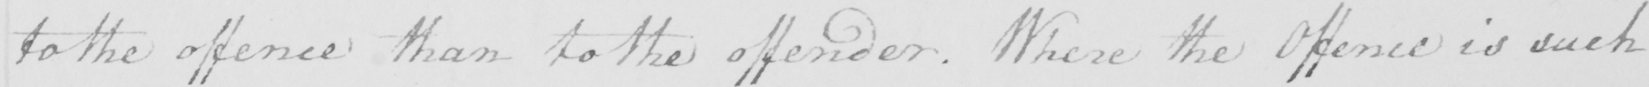Can you read and transcribe this handwriting? to the offence than to the offender . Where the Offence is such 